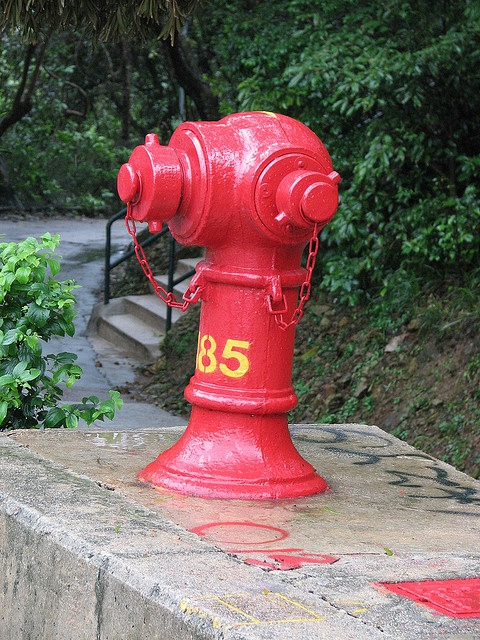Describe the objects in this image and their specific colors. I can see a fire hydrant in black, salmon, brown, and red tones in this image. 